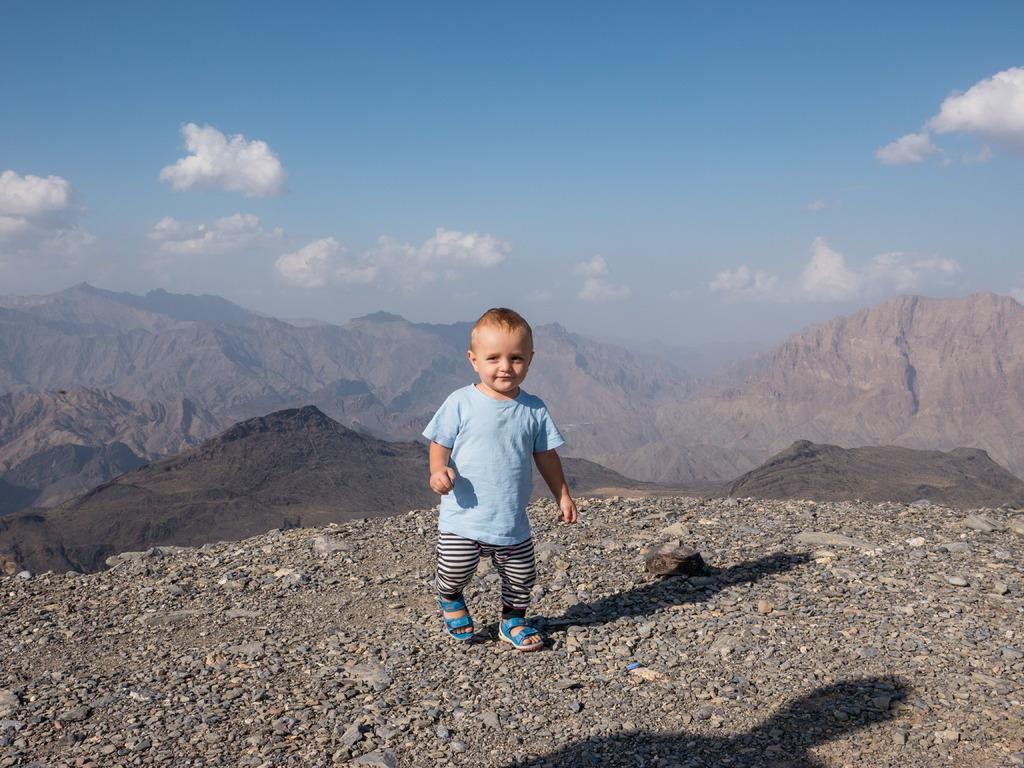What is the main subject of the image? There is a child in the image. What is the child doing in the image? The child is standing on the ground. Can you describe the ground in the image? The ground contains stones. What can be seen in the background of the image? There are mountains in the background of the image. How would you describe the sky in the image? The sky looks cloudy. What type of club does the child belong to in the image? There is no club mentioned or depicted in the image. Is there a doll accompanying the child in the image? There is no doll present in the image. 